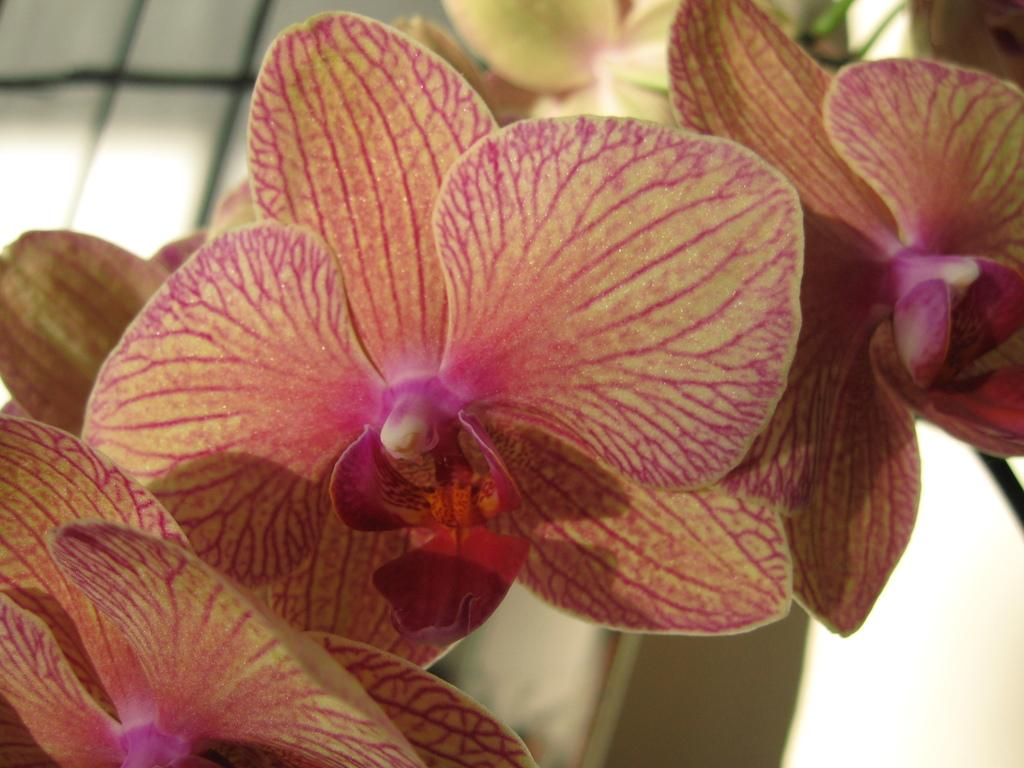What type of living organisms can be seen in the image? Flowers can be seen in the image. Can you describe the flowers in the image? Unfortunately, the facts provided do not give specific details about the flowers. What might be the purpose of the flowers in the image? The image does not provide enough context to determine the purpose of the flowers. How does the beginner feel about the hot fear in the image? There is no beginner, hot fear, or any indication of emotion in the image, as it only features flowers. 